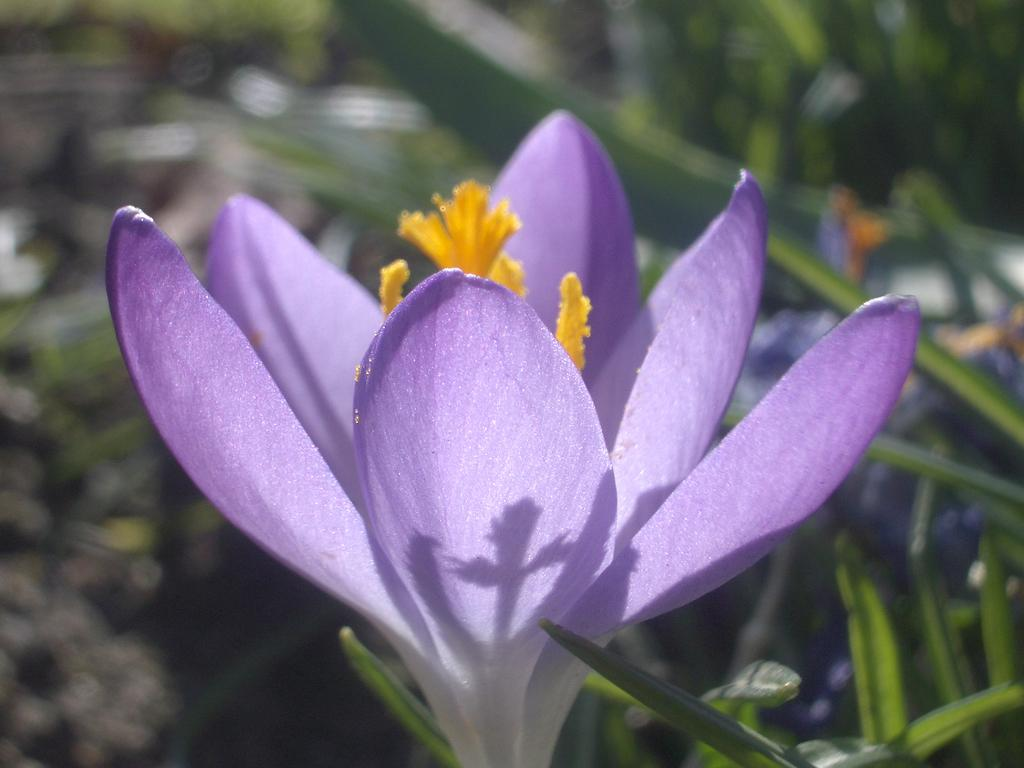What is the main subject of the image? There is a flower in the image. Are there any other plants visible in the image? Yes, there are plants behind the flower. Can you describe the background of the image? The background of the image is blurred. What type of dock can be seen in the image? There is no dock present in the image; it features a flower and plants. How is the drink being distributed in the image? There is no drink present in the image, so it cannot be distributed. 